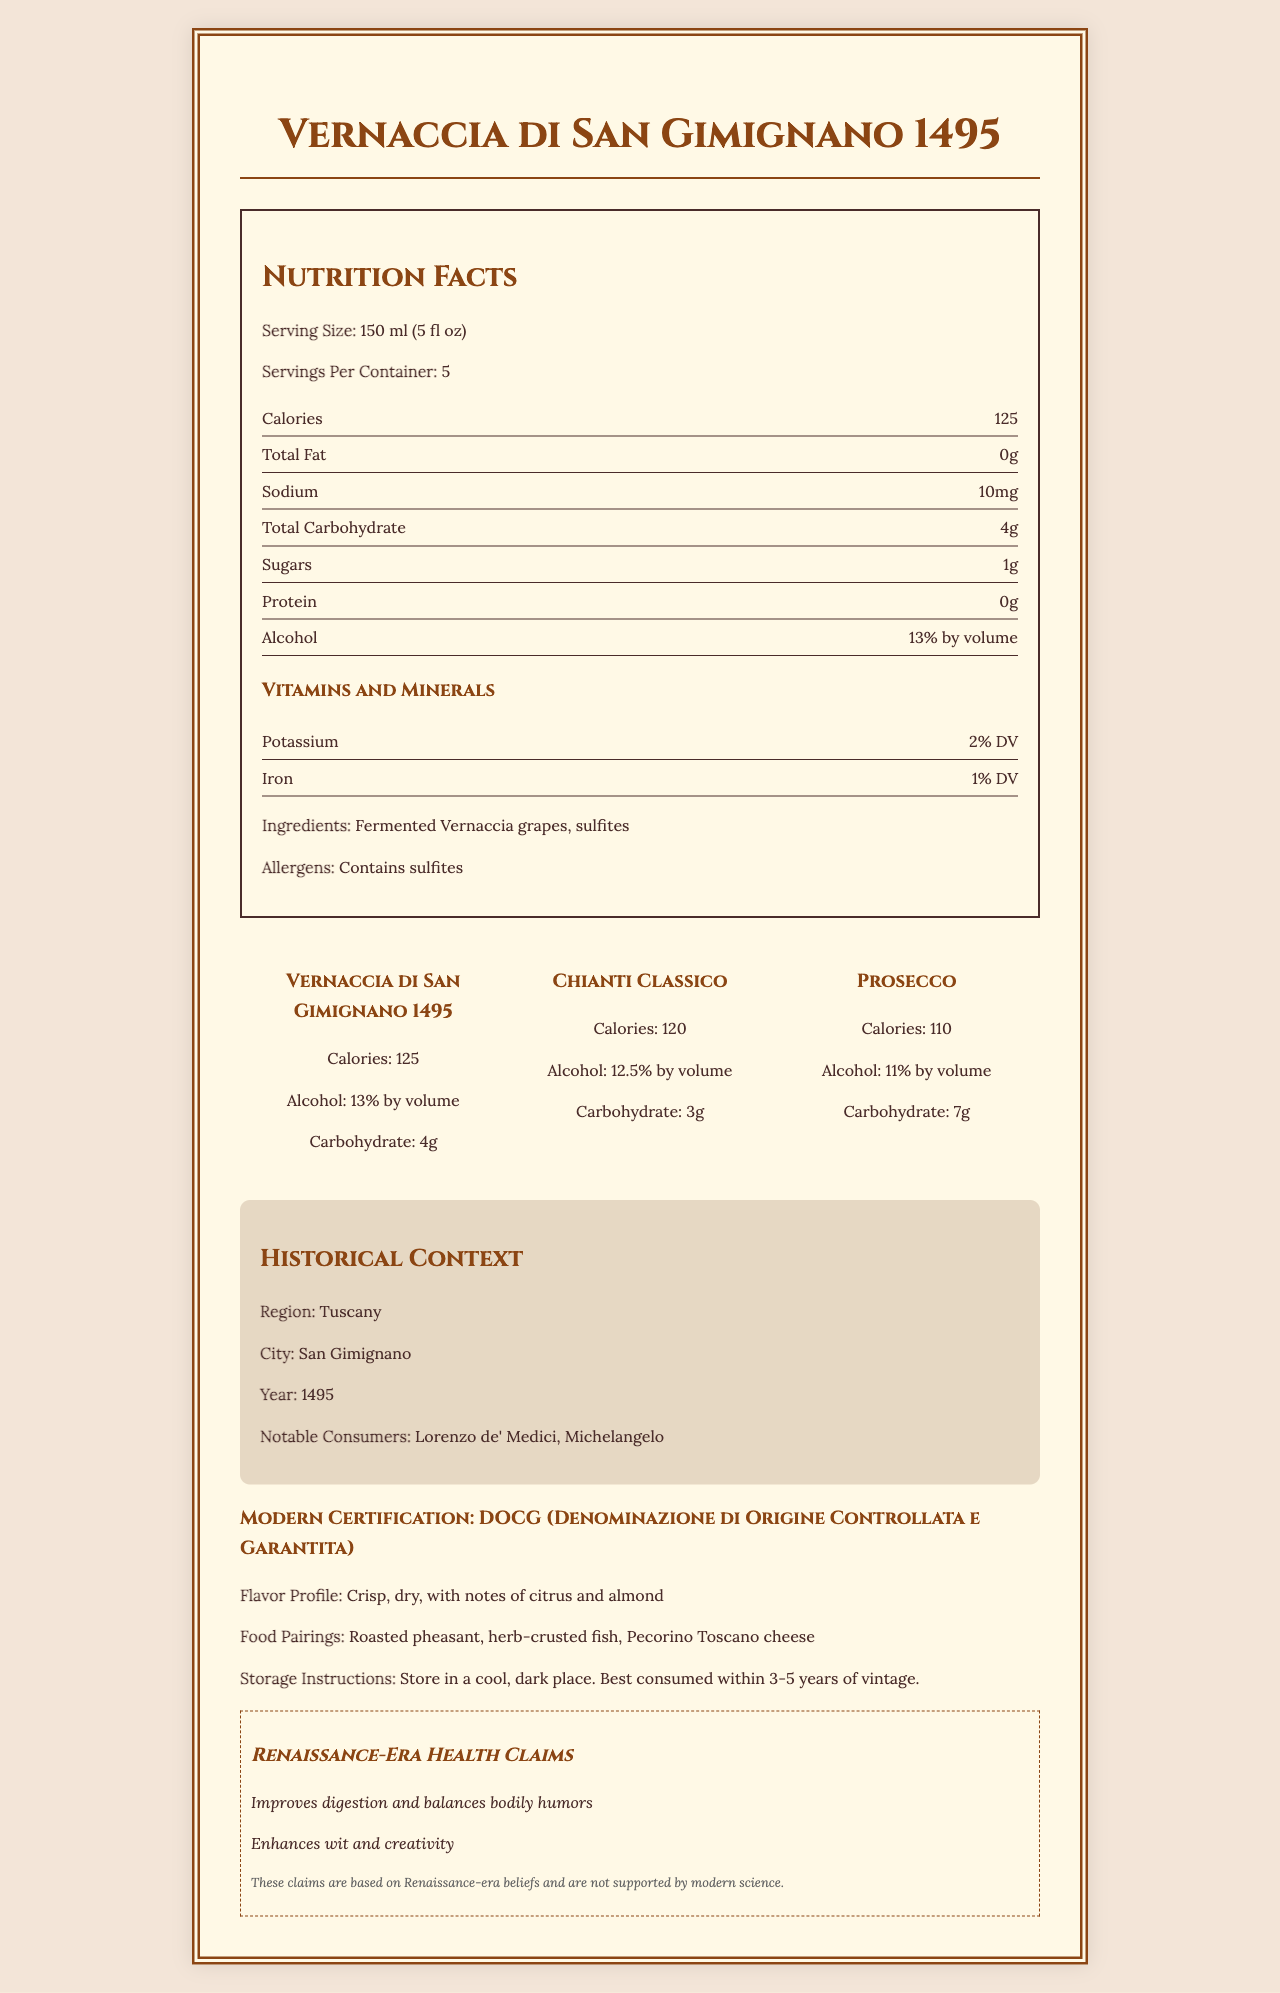which wine has the highest alcohol content? The alcohol content of Vernaccia di San Gimignano 1495 is 13% by volume, which is higher than both Chianti Classico (12.5%) and Prosecco (11%).
Answer: Vernaccia di San Gimignano 1495 what are the serving size and the servings per container for Vernaccia di San Gimignano 1495? According to the document, the serving size is 150 ml (5 fl oz), and there are 5 servings per container.
Answer: 150 ml (5 fl oz) and 5 servings per container name two notable consumers of Vernaccia di San Gimignano 1495 in its historical context The historical context section mentions Lorenzo de' Medici and Michelangelo as notable consumers.
Answer: Lorenzo de' Medici, Michelangelo what are the main ingredients of Vernaccia di San Gimignano 1495? The ingredients listed include fermented Vernaccia grapes and sulfites.
Answer: Fermented Vernaccia grapes, sulfites what were the Renaissance-era health claims associated with Vernaccia di San Gimignano 1495? The document lists two Renaissance-era health claims: "Improves digestion and balances bodily humors" and "Enhances wit and creativity."
Answer: Improves digestion and balances bodily humors, Enhances wit and creativity what should you pair with Vernaccia di San Gimignano 1495? The food pairings listed include roasted pheasant, herb-crusted fish, and Pecorino Toscano cheese.
Answer: Roasted pheasant, herb-crusted fish, Pecorino Toscano cheese which wine has the highest carbohydrate content? Prosecco has a total carbohydrate content of 7g, while Vernaccia di San Gimignano 1495 has 4g and Chianti Classico has 3g.
Answer: Prosecco where should you store Vernaccia di San Gimignano 1495 to maintain its quality? The storage instructions advise storing Vernaccia di San Gimignano 1495 in a cool, dark place.
Answer: In a cool, dark place what modern certification does Vernaccia di San Gimignano 1495 have? The document states that Vernaccia di San Gimignano 1495 has a DOCG certification.
Answer: DOCG (Denominazione di Origine Controllata e Garantita) what flavor notes are associated with Vernaccia di San Gimignano 1495? The flavor profile mentions notes of citrus and almond.
Answer: Citrus and almond which wine contains the least amount of calories per serving? Prosecco has 110 calories per serving, compared to Vernaccia di San Gimignano 1495 with 125 and Chianti Classico with 120.
Answer: Prosecco how much protein is in a serving of Vernaccia di San Gimignano 1495? The nutritional facts state that there is 0g of protein per serving.
Answer: 0g is Vernaccia di San Gimignano 1495 considered a sweet wine? The flavor profile describes it as "crisp, dry," which indicates it is not a sweet wine.
Answer: No which opera did Michelangelo reportedly prefer? There is no information about Michelangelo's preference for any opera in the document.
Answer: Not enough information what vitamins and minerals are present in Vernaccia di San Gimignano 1495? The vitamins and minerals section lists potassium at 2% daily value and iron at 1% daily value.
Answer: Potassium (2% DV), Iron (1% DV) what is a brief summary of the document? The document encapsulates details about Vernaccia di San Gimignano 1495's nutrition, ingredients, historical context, modern certification, flavor profile, food pairings, and storage instructions, alongside a comparison to modern Italian wines and Renaissance-era health claims.
Answer: This document presents nutrition facts and other details about Vernaccia di San Gimignano 1495, a Renaissance-era Tuscan wine. It includes the serving size, calories, and other nutritional information, compares it to modern Italian wines (Chianti Classico and Prosecco), and provides historical context. Additionally, it describes the flavor profile, food pairings, and storage instructions and mentions Renaissance-era health claims. 